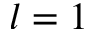Convert formula to latex. <formula><loc_0><loc_0><loc_500><loc_500>l = 1</formula> 